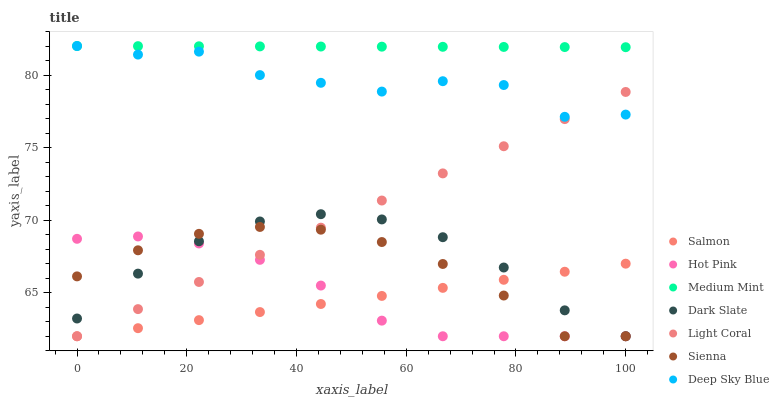Does Salmon have the minimum area under the curve?
Answer yes or no. Yes. Does Medium Mint have the maximum area under the curve?
Answer yes or no. Yes. Does Sienna have the minimum area under the curve?
Answer yes or no. No. Does Sienna have the maximum area under the curve?
Answer yes or no. No. Is Salmon the smoothest?
Answer yes or no. Yes. Is Deep Sky Blue the roughest?
Answer yes or no. Yes. Is Sienna the smoothest?
Answer yes or no. No. Is Sienna the roughest?
Answer yes or no. No. Does Sienna have the lowest value?
Answer yes or no. Yes. Does Deep Sky Blue have the lowest value?
Answer yes or no. No. Does Deep Sky Blue have the highest value?
Answer yes or no. Yes. Does Sienna have the highest value?
Answer yes or no. No. Is Salmon less than Medium Mint?
Answer yes or no. Yes. Is Medium Mint greater than Light Coral?
Answer yes or no. Yes. Does Hot Pink intersect Sienna?
Answer yes or no. Yes. Is Hot Pink less than Sienna?
Answer yes or no. No. Is Hot Pink greater than Sienna?
Answer yes or no. No. Does Salmon intersect Medium Mint?
Answer yes or no. No. 